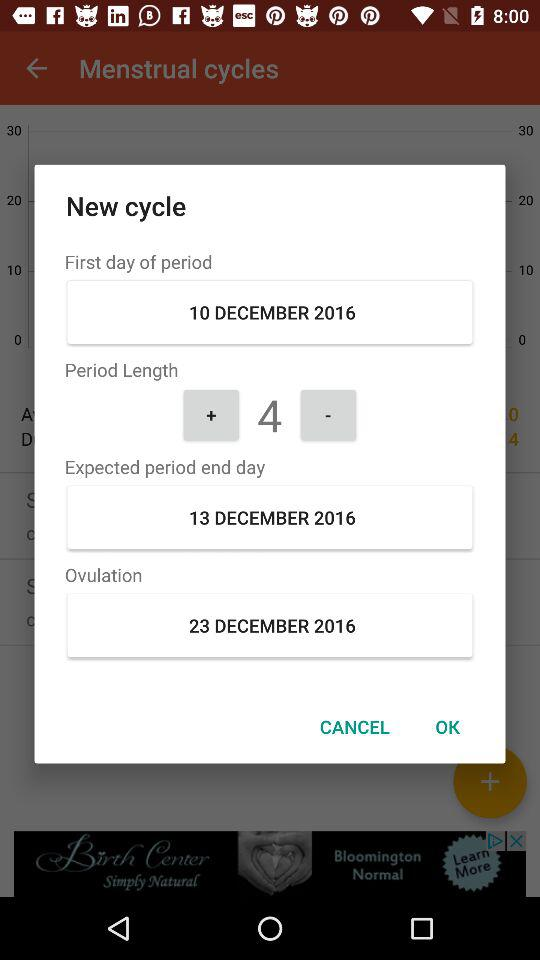What is the ovulation date? The ovulation date is December 23, 2016. 